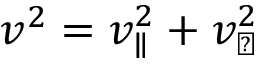<formula> <loc_0><loc_0><loc_500><loc_500>v ^ { 2 } = v _ { \| } ^ { 2 } + v _ { \perp } ^ { 2 }</formula> 